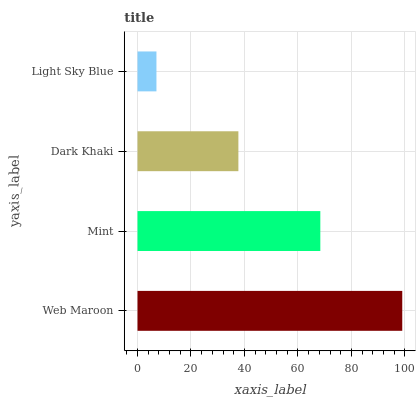Is Light Sky Blue the minimum?
Answer yes or no. Yes. Is Web Maroon the maximum?
Answer yes or no. Yes. Is Mint the minimum?
Answer yes or no. No. Is Mint the maximum?
Answer yes or no. No. Is Web Maroon greater than Mint?
Answer yes or no. Yes. Is Mint less than Web Maroon?
Answer yes or no. Yes. Is Mint greater than Web Maroon?
Answer yes or no. No. Is Web Maroon less than Mint?
Answer yes or no. No. Is Mint the high median?
Answer yes or no. Yes. Is Dark Khaki the low median?
Answer yes or no. Yes. Is Dark Khaki the high median?
Answer yes or no. No. Is Mint the low median?
Answer yes or no. No. 